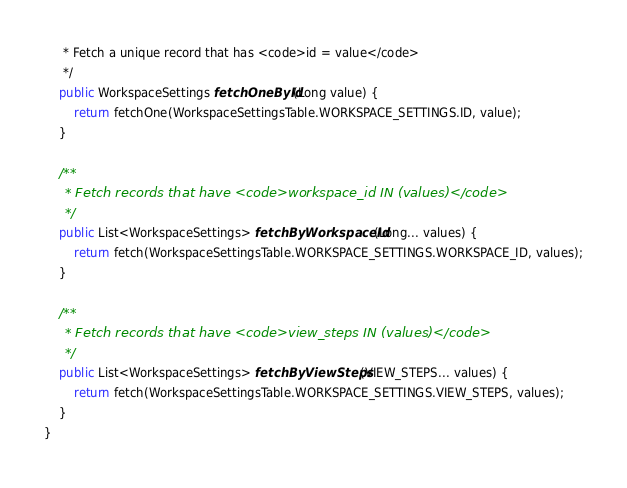<code> <loc_0><loc_0><loc_500><loc_500><_Java_>	 * Fetch a unique record that has <code>id = value</code>
	 */
	public WorkspaceSettings fetchOneById(Long value) {
		return fetchOne(WorkspaceSettingsTable.WORKSPACE_SETTINGS.ID, value);
	}

	/**
	 * Fetch records that have <code>workspace_id IN (values)</code>
	 */
	public List<WorkspaceSettings> fetchByWorkspaceId(Long... values) {
		return fetch(WorkspaceSettingsTable.WORKSPACE_SETTINGS.WORKSPACE_ID, values);
	}

	/**
	 * Fetch records that have <code>view_steps IN (values)</code>
	 */
	public List<WorkspaceSettings> fetchByViewSteps(VIEW_STEPS... values) {
		return fetch(WorkspaceSettingsTable.WORKSPACE_SETTINGS.VIEW_STEPS, values);
	}
}
</code> 